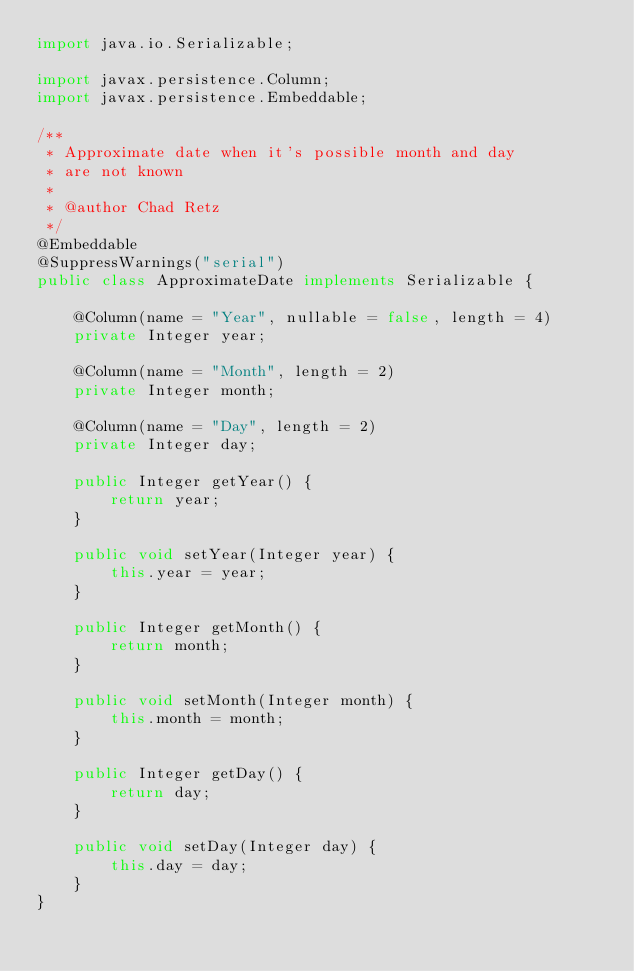<code> <loc_0><loc_0><loc_500><loc_500><_Java_>import java.io.Serializable;

import javax.persistence.Column;
import javax.persistence.Embeddable;

/**
 * Approximate date when it's possible month and day
 * are not known
 * 
 * @author Chad Retz
 */
@Embeddable
@SuppressWarnings("serial")
public class ApproximateDate implements Serializable {
    
    @Column(name = "Year", nullable = false, length = 4)
    private Integer year;
    
    @Column(name = "Month", length = 2)
    private Integer month;
    
    @Column(name = "Day", length = 2)
    private Integer day;

    public Integer getYear() {
        return year;
    }

    public void setYear(Integer year) {
        this.year = year;
    }

    public Integer getMonth() {
        return month;
    }

    public void setMonth(Integer month) {
        this.month = month;
    }

    public Integer getDay() {
        return day;
    }

    public void setDay(Integer day) {
        this.day = day;
    }
}
</code> 